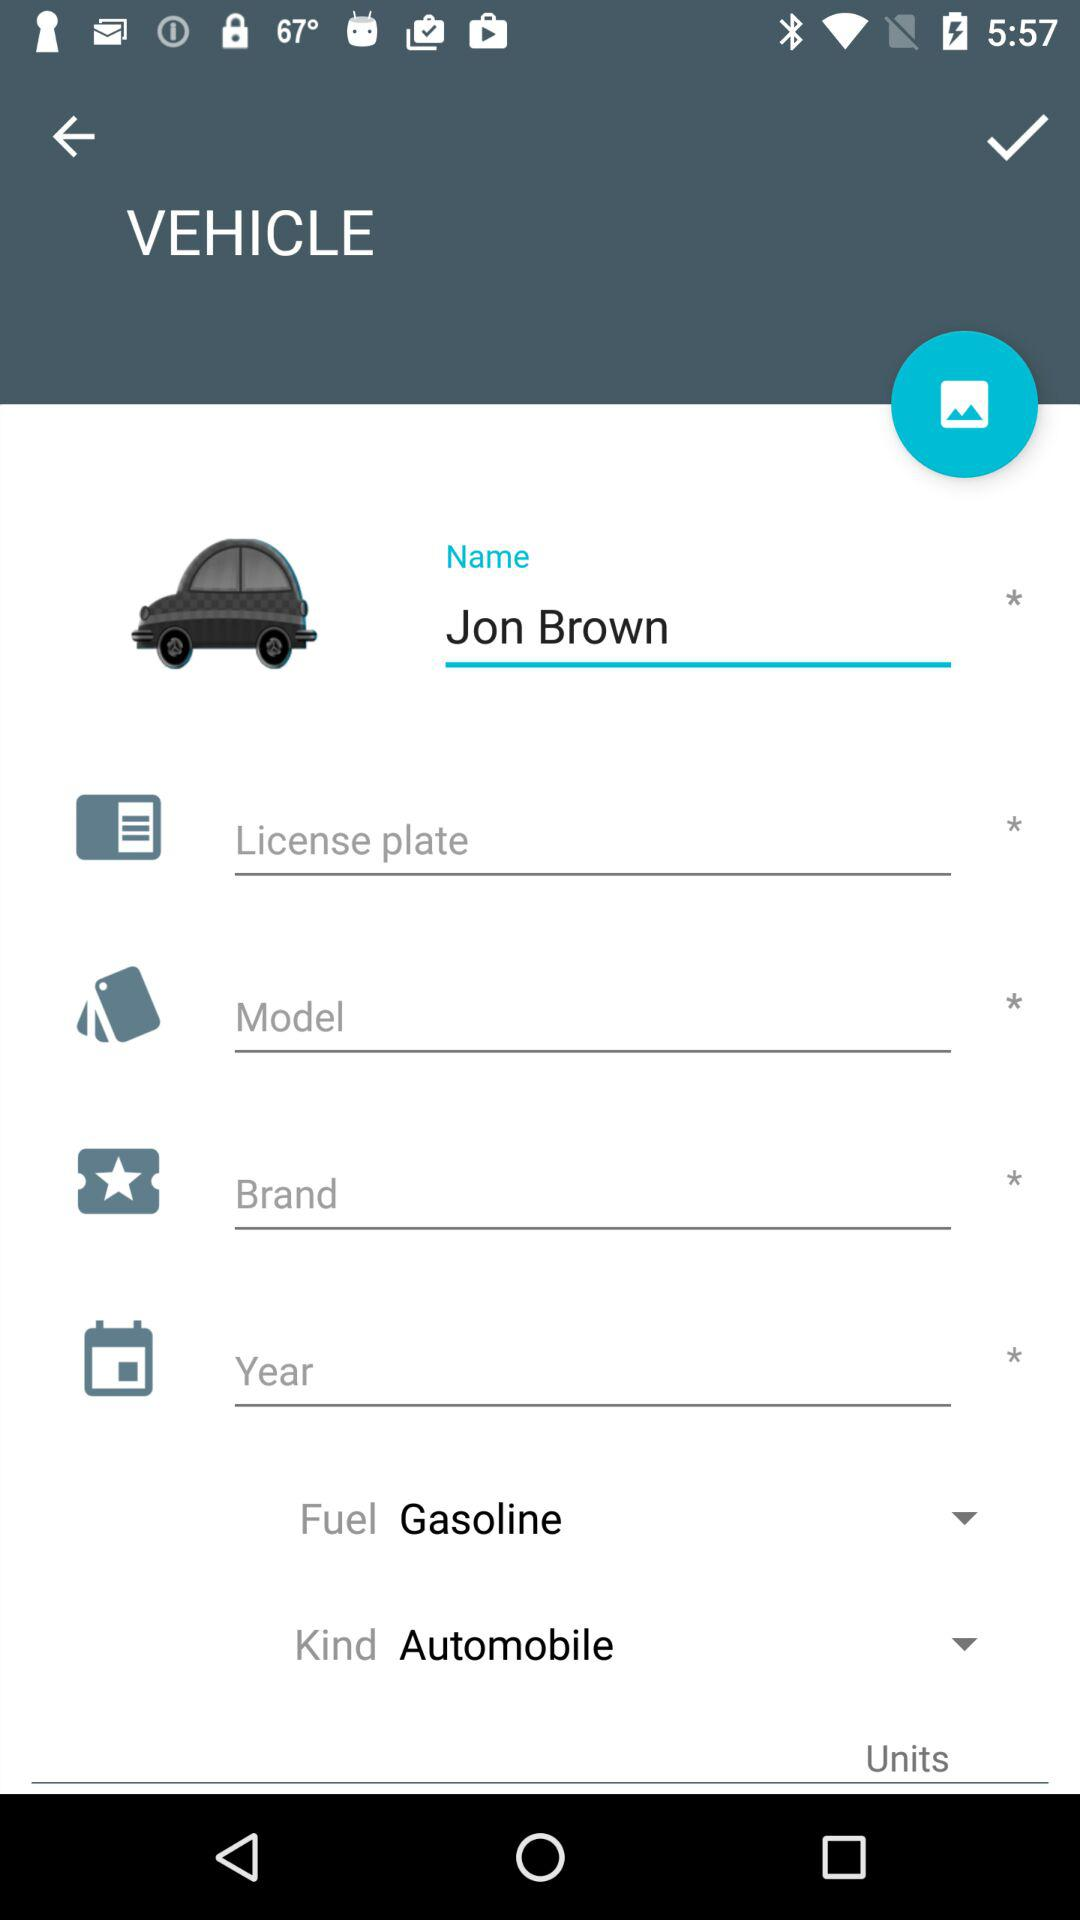What is selected for fuel? The option "Gasoline" is selected for fuel. 